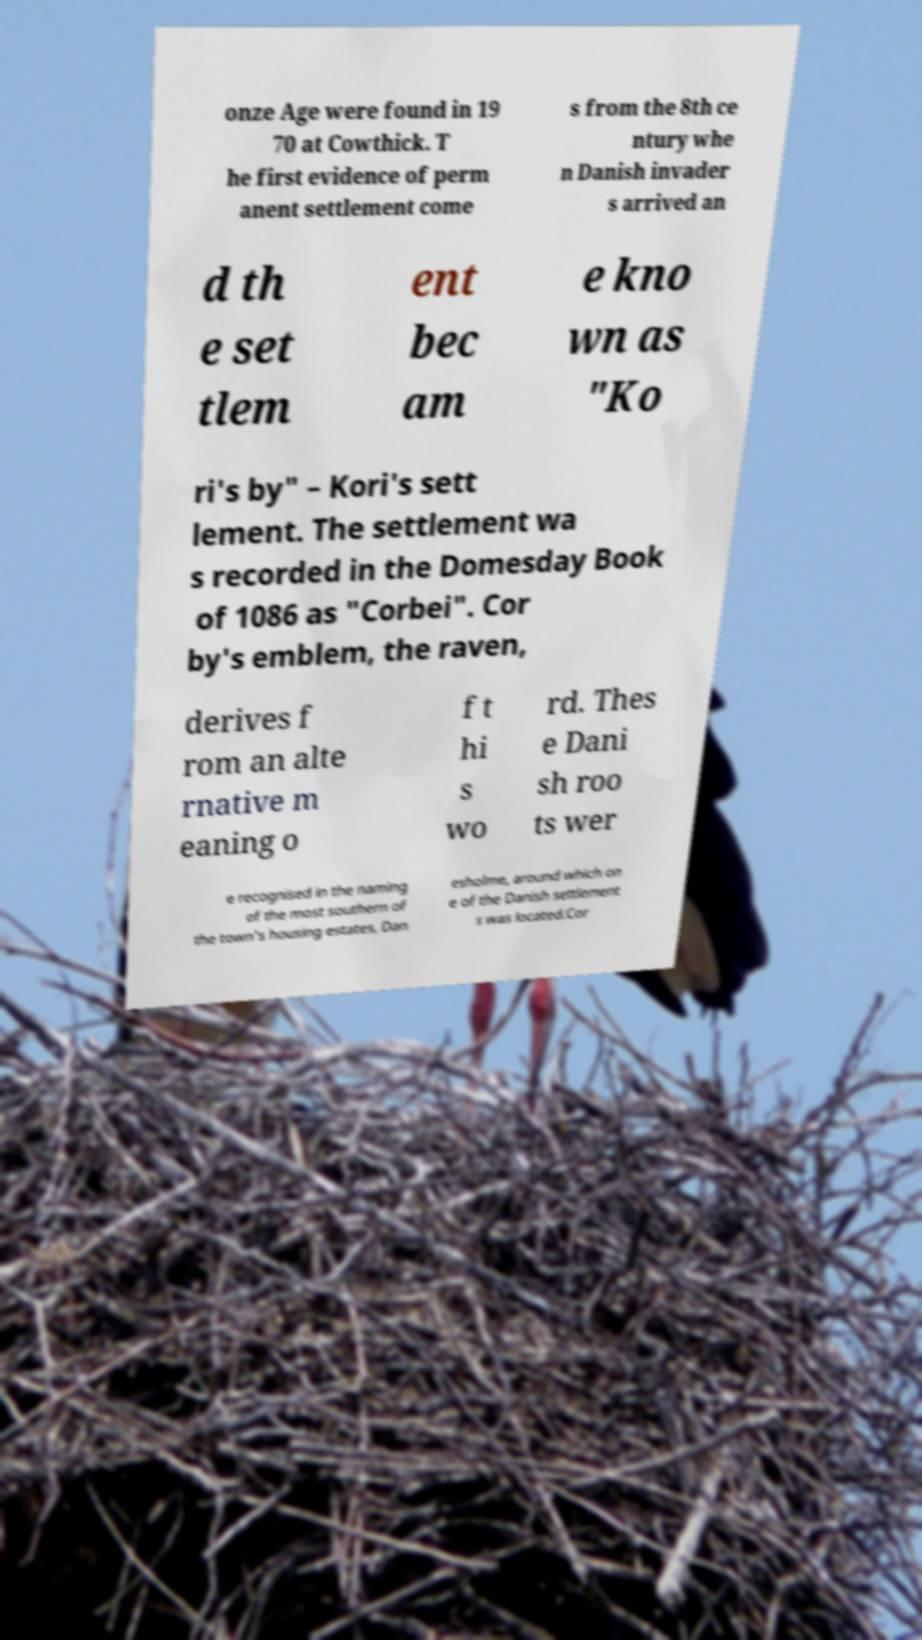Can you read and provide the text displayed in the image?This photo seems to have some interesting text. Can you extract and type it out for me? onze Age were found in 19 70 at Cowthick. T he first evidence of perm anent settlement come s from the 8th ce ntury whe n Danish invader s arrived an d th e set tlem ent bec am e kno wn as "Ko ri's by" – Kori's sett lement. The settlement wa s recorded in the Domesday Book of 1086 as "Corbei". Cor by's emblem, the raven, derives f rom an alte rnative m eaning o f t hi s wo rd. Thes e Dani sh roo ts wer e recognised in the naming of the most southern of the town's housing estates, Dan esholme, around which on e of the Danish settlement s was located.Cor 